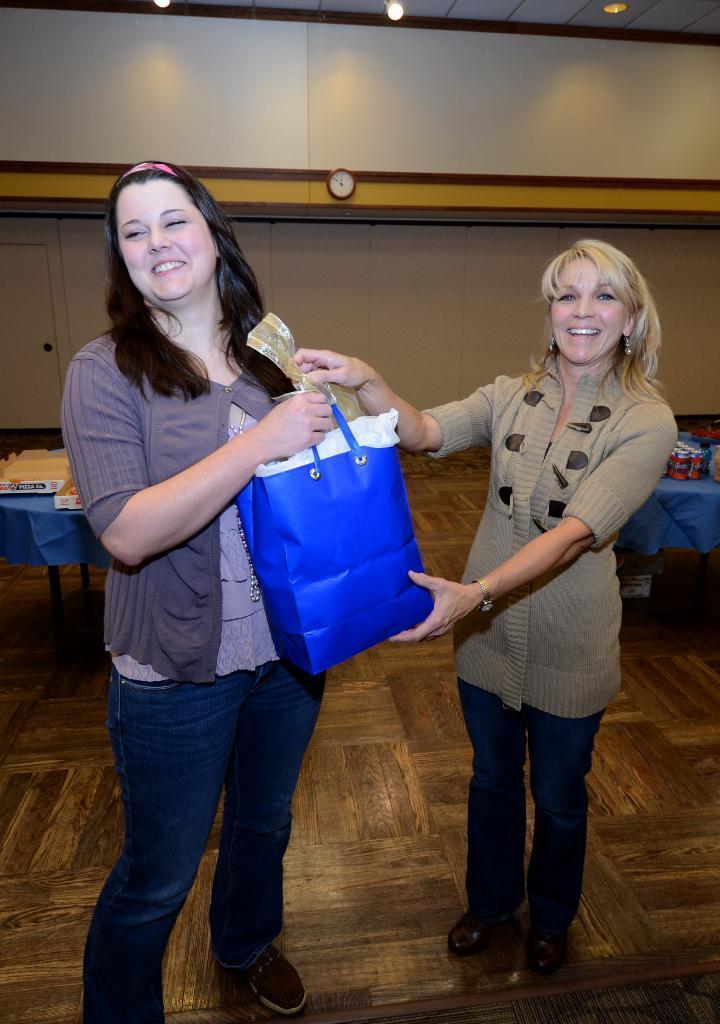Please provide a concise description of this image. Here we can see two women standing on the floor. They are smiling and holding a bag with their hands. There are tables. On the table we can see clothes. In the background we can see wall, clock, and lights. 